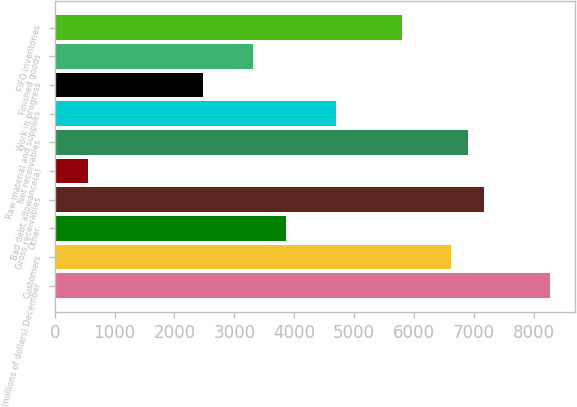Convert chart. <chart><loc_0><loc_0><loc_500><loc_500><bar_chart><fcel>(millions of dollars) December<fcel>Customers<fcel>Other<fcel>Gross receivables<fcel>Bad debt allowance(a)<fcel>Net receivables<fcel>Raw material and supplies<fcel>Work in progress<fcel>Finished goods<fcel>FIFO inventories<nl><fcel>8278.4<fcel>6623.18<fcel>3864.48<fcel>7174.92<fcel>554.04<fcel>6899.05<fcel>4692.09<fcel>2485.13<fcel>3312.74<fcel>5795.57<nl></chart> 